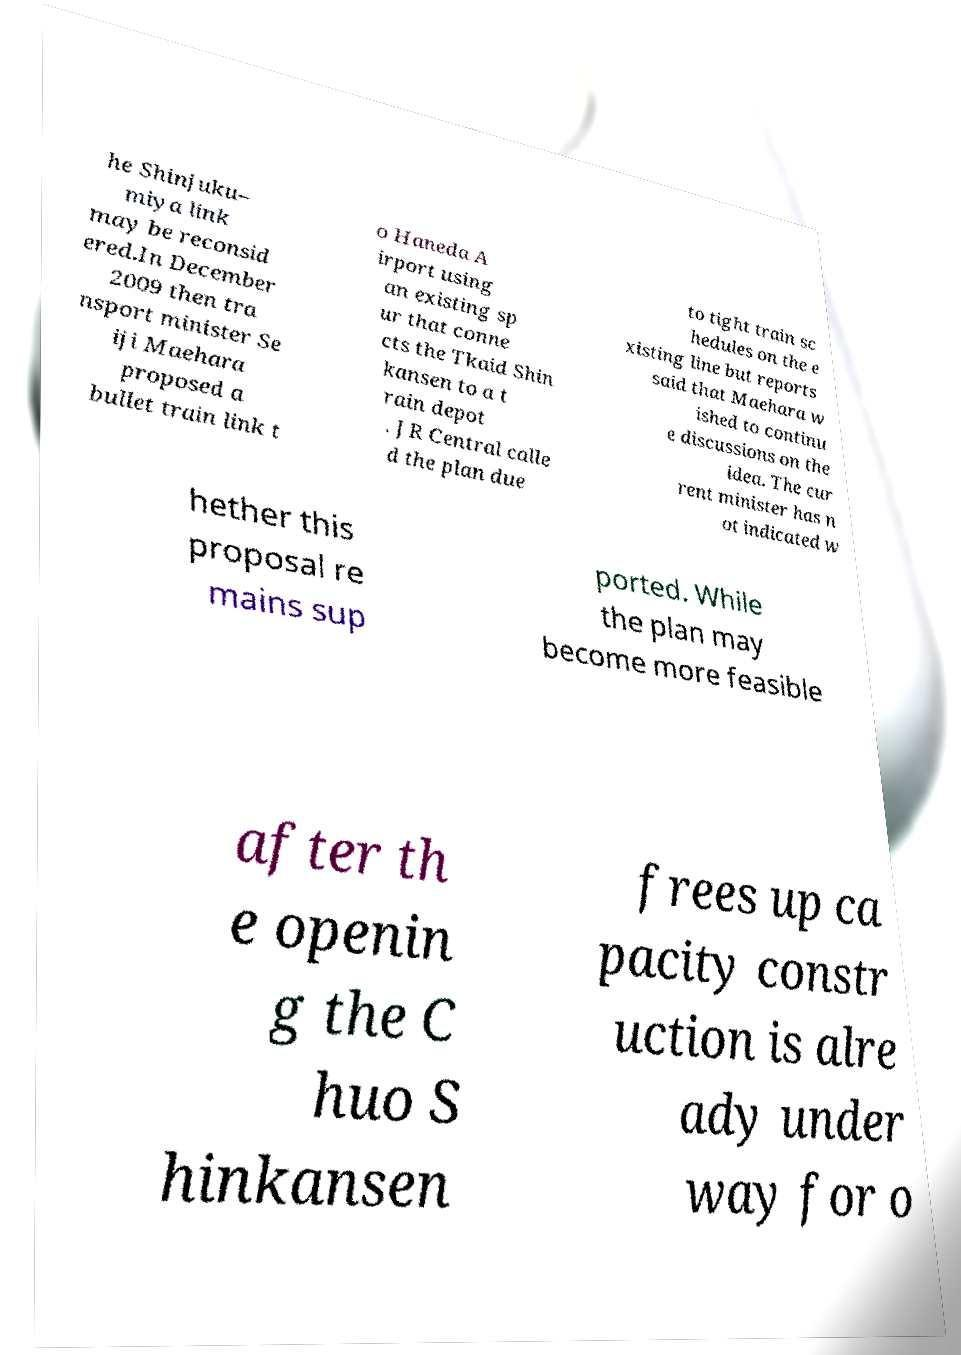I need the written content from this picture converted into text. Can you do that? he Shinjuku– miya link may be reconsid ered.In December 2009 then tra nsport minister Se iji Maehara proposed a bullet train link t o Haneda A irport using an existing sp ur that conne cts the Tkaid Shin kansen to a t rain depot . JR Central calle d the plan due to tight train sc hedules on the e xisting line but reports said that Maehara w ished to continu e discussions on the idea. The cur rent minister has n ot indicated w hether this proposal re mains sup ported. While the plan may become more feasible after th e openin g the C huo S hinkansen frees up ca pacity constr uction is alre ady under way for o 